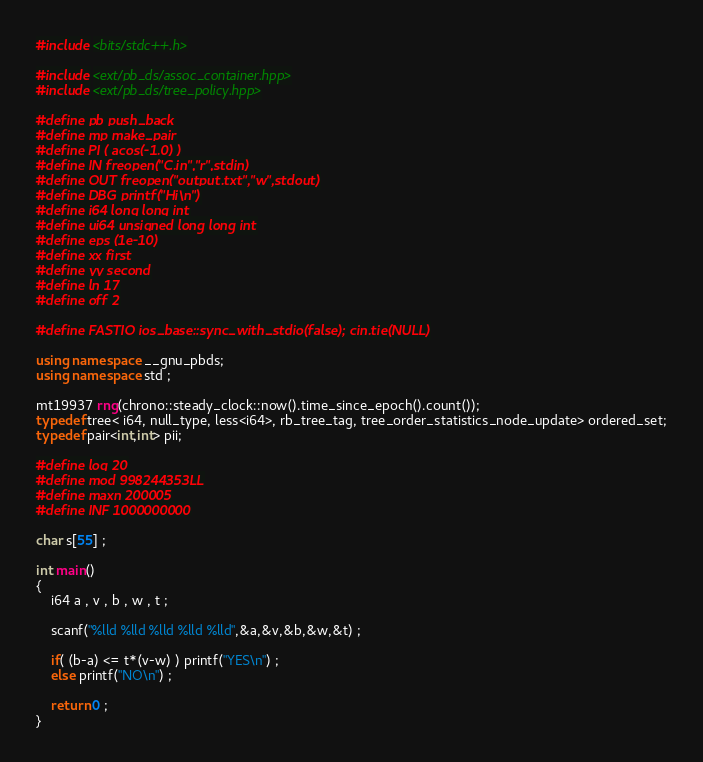Convert code to text. <code><loc_0><loc_0><loc_500><loc_500><_C++_>#include <bits/stdc++.h>

#include <ext/pb_ds/assoc_container.hpp>
#include <ext/pb_ds/tree_policy.hpp>

#define pb push_back
#define mp make_pair
#define PI ( acos(-1.0) )
#define IN freopen("C.in","r",stdin)
#define OUT freopen("output.txt","w",stdout)
#define DBG printf("Hi\n")
#define i64 long long int
#define ui64 unsigned long long int
#define eps (1e-10)
#define xx first
#define yy second
#define ln 17
#define off 2

#define FASTIO ios_base::sync_with_stdio(false); cin.tie(NULL)

using namespace __gnu_pbds;
using namespace std ;

mt19937 rng(chrono::steady_clock::now().time_since_epoch().count());
typedef tree< i64, null_type, less<i64>, rb_tree_tag, tree_order_statistics_node_update> ordered_set;
typedef pair<int,int> pii;

#define log 20
#define mod 998244353LL
#define maxn 200005
#define INF 1000000000

char s[55] ;

int main()
{
    i64 a , v , b , w , t ;

    scanf("%lld %lld %lld %lld %lld",&a,&v,&b,&w,&t) ;

    if( (b-a) <= t*(v-w) ) printf("YES\n") ;
    else printf("NO\n") ;

    return 0 ;
}
</code> 